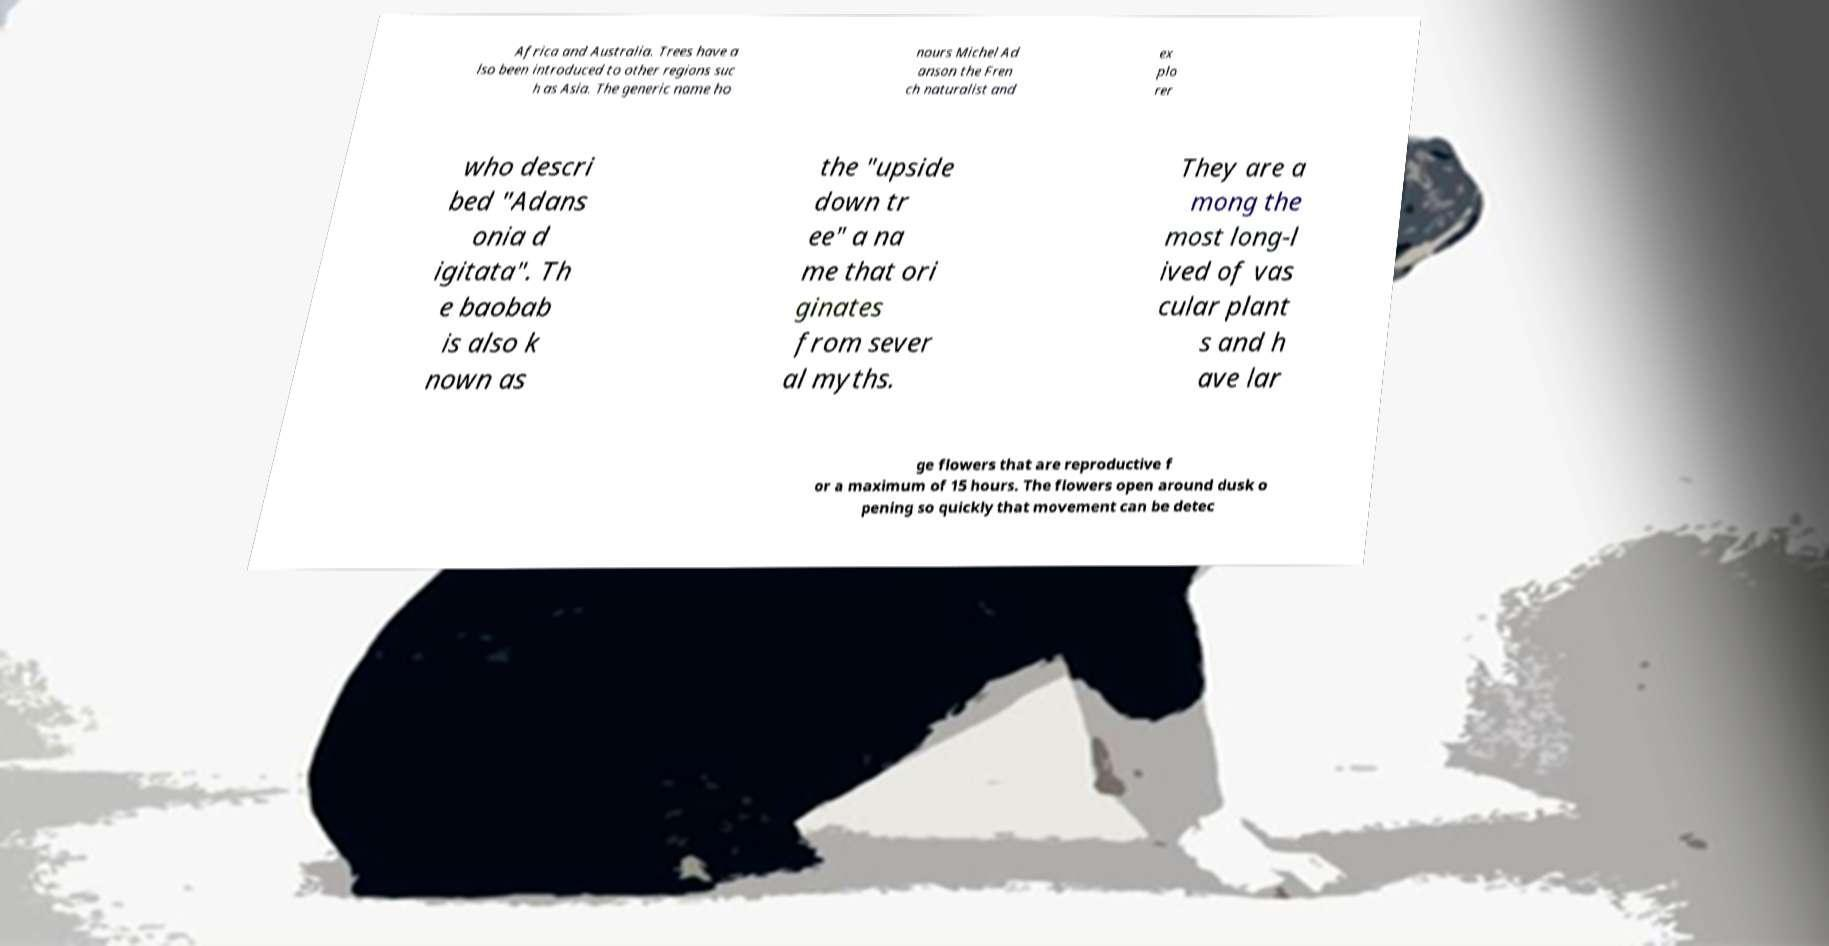I need the written content from this picture converted into text. Can you do that? Africa and Australia. Trees have a lso been introduced to other regions suc h as Asia. The generic name ho nours Michel Ad anson the Fren ch naturalist and ex plo rer who descri bed "Adans onia d igitata". Th e baobab is also k nown as the "upside down tr ee" a na me that ori ginates from sever al myths. They are a mong the most long-l ived of vas cular plant s and h ave lar ge flowers that are reproductive f or a maximum of 15 hours. The flowers open around dusk o pening so quickly that movement can be detec 